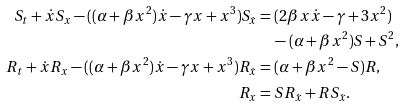<formula> <loc_0><loc_0><loc_500><loc_500>S _ { t } + \dot { x } S _ { x } - ( ( \alpha + \beta x ^ { 2 } ) \dot { x } - \gamma x + x ^ { 3 } ) S _ { \dot { x } } & = ( 2 \beta x \dot { x } - \gamma + 3 x ^ { 2 } ) \\ & \quad - ( \alpha + \beta x ^ { 2 } ) S + S ^ { 2 } , \\ R _ { t } + \dot { x } R _ { x } - ( ( \alpha + \beta x ^ { 2 } ) \dot { x } - \gamma x + x ^ { 3 } ) R _ { \dot { x } } & = ( \alpha + \beta x ^ { 2 } - S ) R , \\ R _ { x } & = S R _ { \dot { x } } + R S _ { \dot { x } } .</formula> 